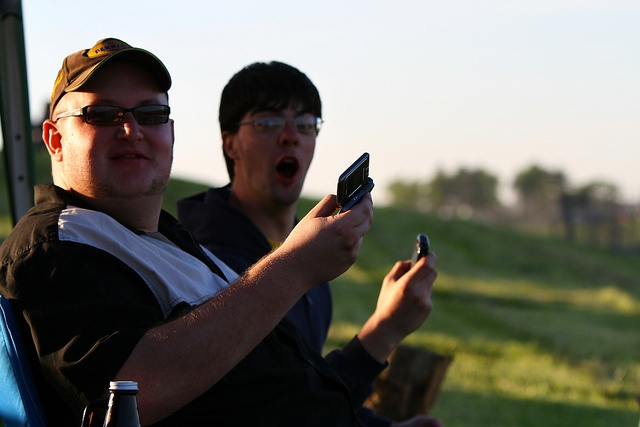Describe the objects in this image and their specific colors. I can see people in black, ivory, maroon, and gray tones, people in black, maroon, gray, and lightgray tones, bottle in black, gray, and white tones, cell phone in black, navy, gray, and darkblue tones, and cell phone in black, gray, and darkgreen tones in this image. 